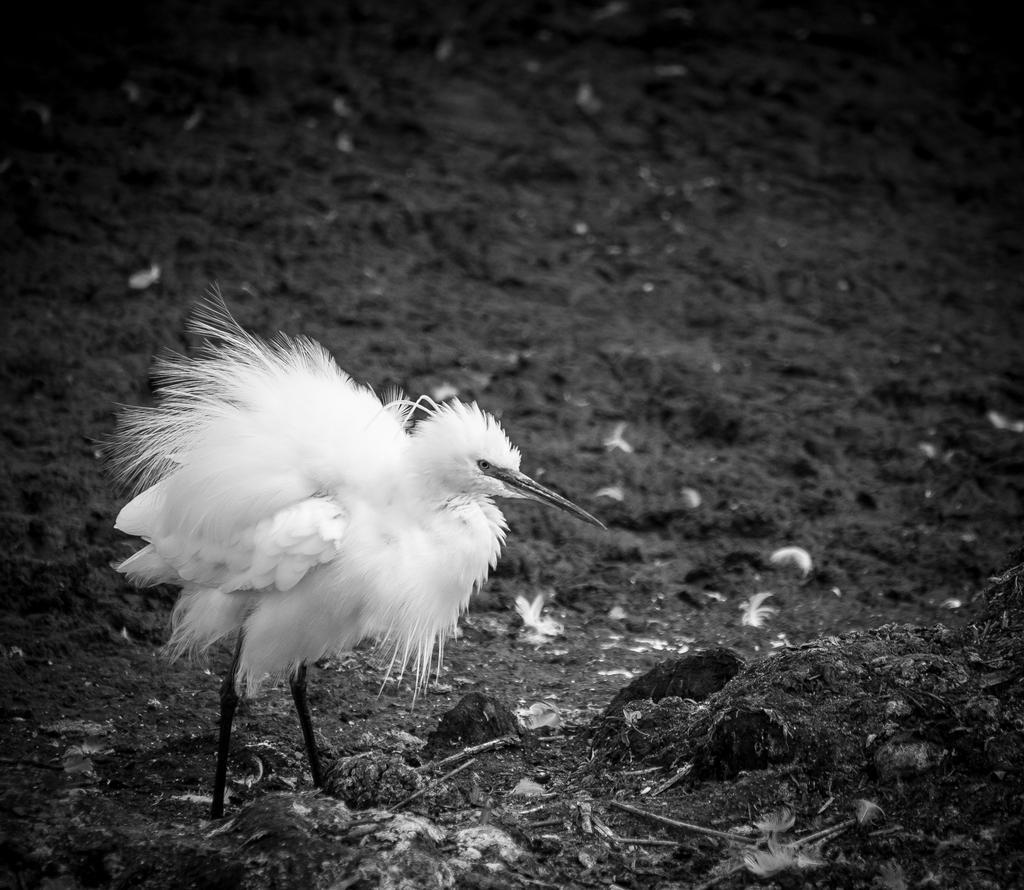How would you summarize this image in a sentence or two? In this picture we can see a bird in the front, at the bottom there is soil, it is a black and white picture. 